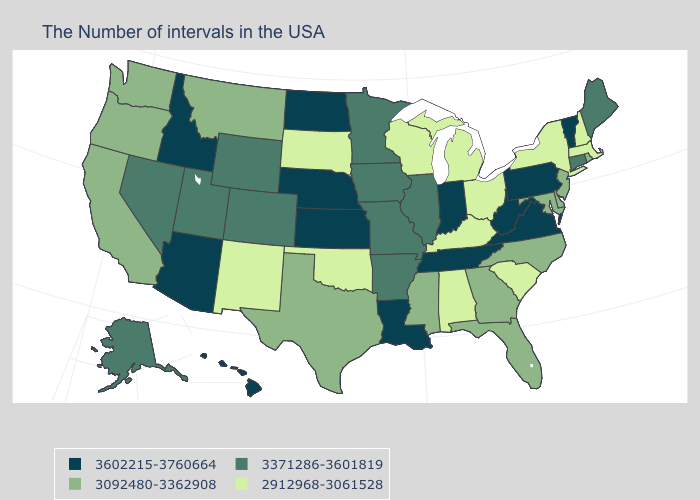What is the lowest value in the MidWest?
Write a very short answer. 2912968-3061528. What is the value of North Carolina?
Answer briefly. 3092480-3362908. What is the highest value in states that border Maine?
Keep it brief. 2912968-3061528. Does Colorado have the highest value in the West?
Answer briefly. No. Name the states that have a value in the range 3371286-3601819?
Concise answer only. Maine, Connecticut, Illinois, Missouri, Arkansas, Minnesota, Iowa, Wyoming, Colorado, Utah, Nevada, Alaska. Name the states that have a value in the range 2912968-3061528?
Be succinct. Massachusetts, New Hampshire, New York, South Carolina, Ohio, Michigan, Kentucky, Alabama, Wisconsin, Oklahoma, South Dakota, New Mexico. What is the value of Massachusetts?
Keep it brief. 2912968-3061528. What is the value of Massachusetts?
Write a very short answer. 2912968-3061528. Which states hav the highest value in the South?
Concise answer only. Virginia, West Virginia, Tennessee, Louisiana. Which states have the lowest value in the South?
Keep it brief. South Carolina, Kentucky, Alabama, Oklahoma. Does Minnesota have the same value as Iowa?
Answer briefly. Yes. Name the states that have a value in the range 2912968-3061528?
Answer briefly. Massachusetts, New Hampshire, New York, South Carolina, Ohio, Michigan, Kentucky, Alabama, Wisconsin, Oklahoma, South Dakota, New Mexico. Name the states that have a value in the range 3092480-3362908?
Write a very short answer. Rhode Island, New Jersey, Delaware, Maryland, North Carolina, Florida, Georgia, Mississippi, Texas, Montana, California, Washington, Oregon. Among the states that border Rhode Island , which have the lowest value?
Concise answer only. Massachusetts. What is the value of Montana?
Be succinct. 3092480-3362908. 